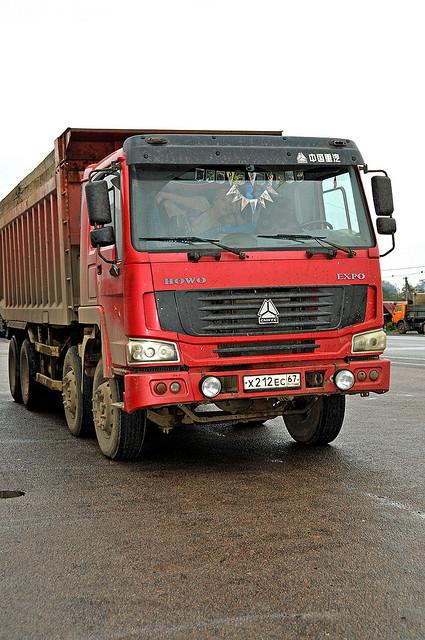Are the windshield wipers on?
Quick response, please. No. What is the brand name on the truck?
Write a very short answer. Mercedes. What color is the truck?
Quick response, please. Red. What color is the outside of this vehicle?
Answer briefly. Red. What brand is this truck?
Quick response, please. Mercedes. What type of truck is this?
Answer briefly. Dump. Could this be a tour bus?
Be succinct. No. What brand is the bus?
Answer briefly. Mercedes. What brand of truck is this?
Answer briefly. How. What numbers are on the front of the truck?
Short answer required. 512. How many tires are on the truck?
Answer briefly. 8. Is this a Mack truck?
Write a very short answer. No. 